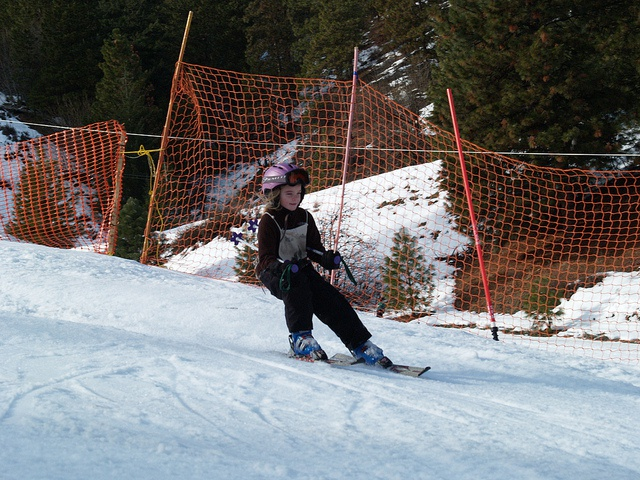Describe the objects in this image and their specific colors. I can see people in black, gray, navy, and darkgray tones and skis in black, darkgray, and gray tones in this image. 